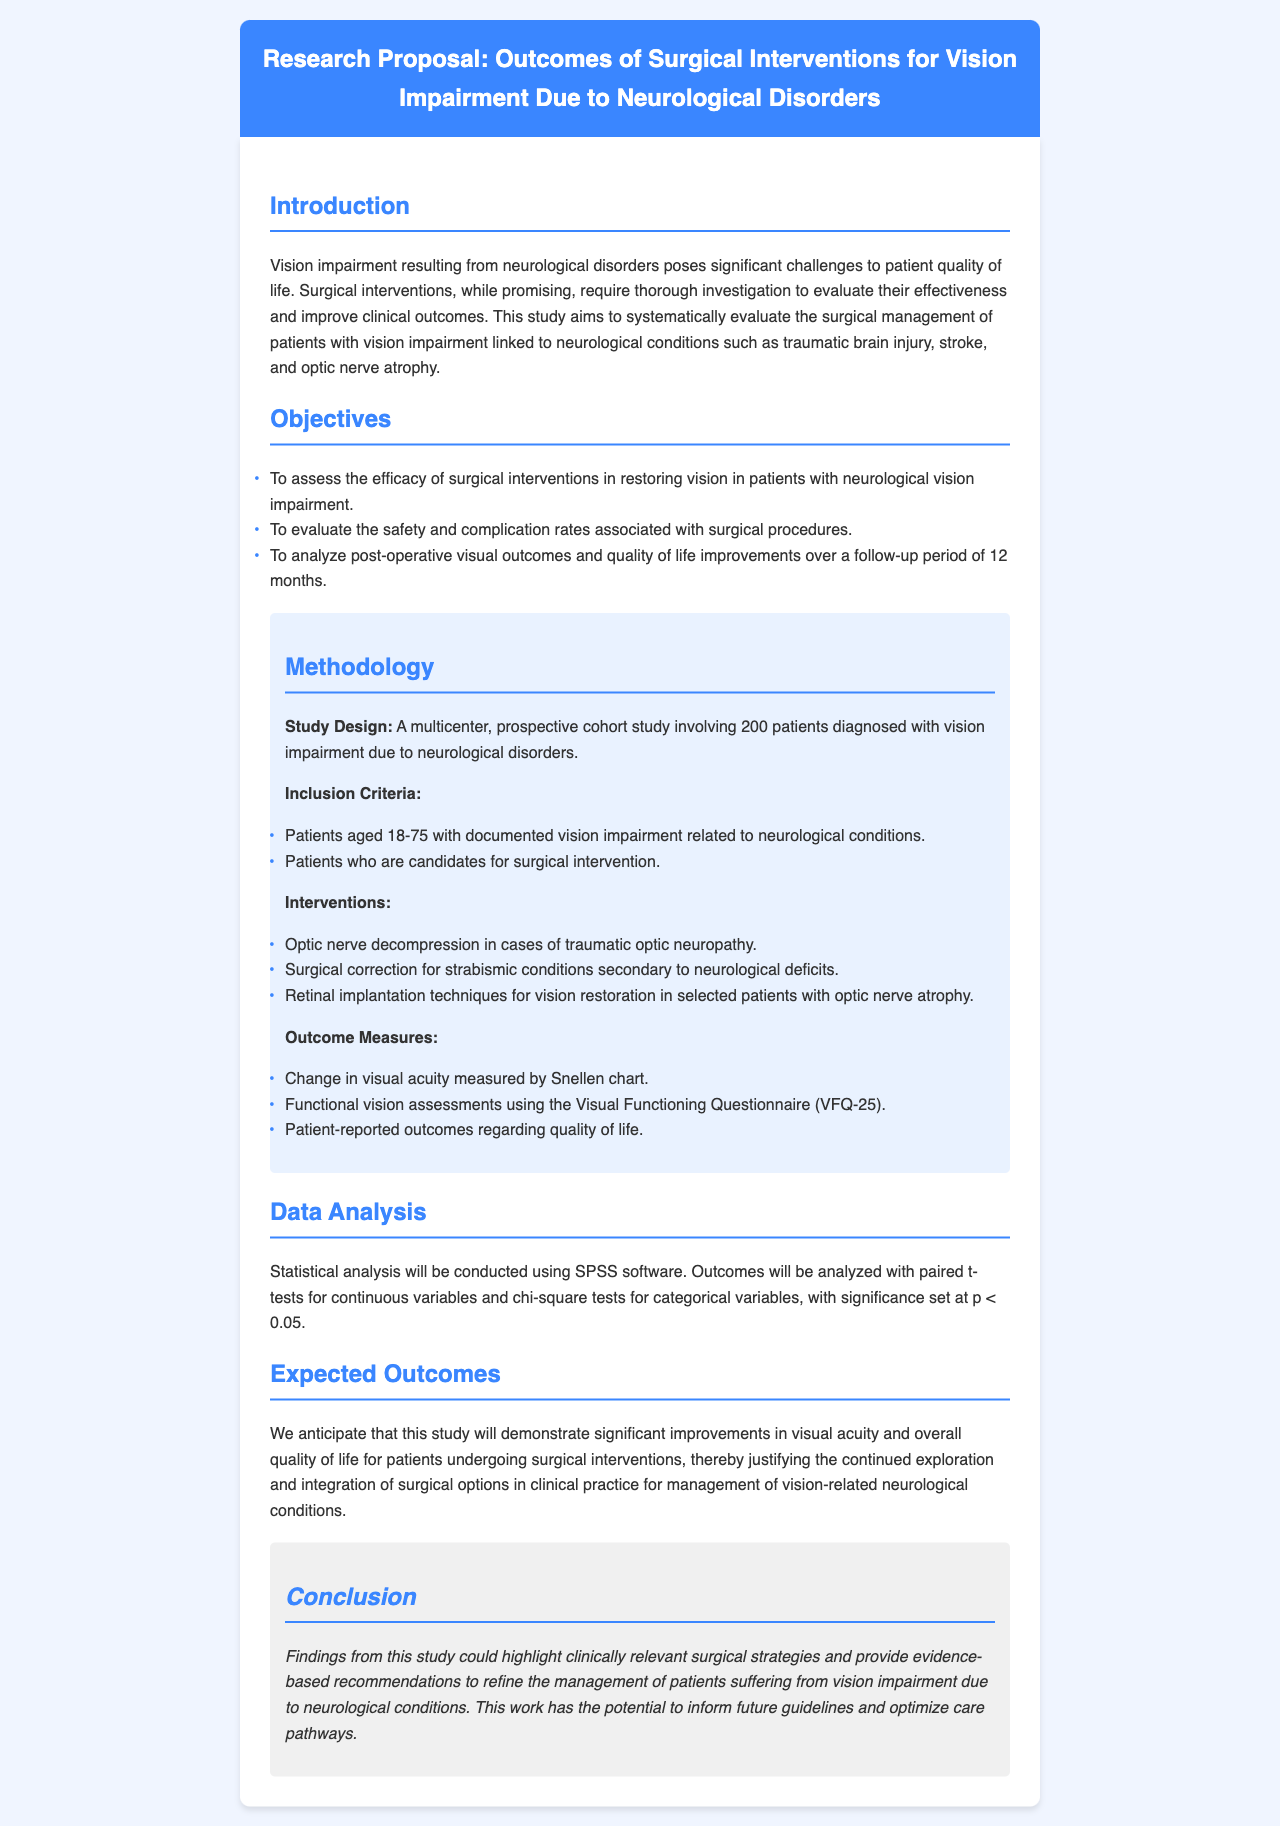What is the title of the research proposal? The title of the research proposal is found at the top of the document.
Answer: Outcomes of Surgical Interventions for Vision Impairment Due to Neurological Disorders How many patients will the study involve? The number of patients involved in the study is stated in the methodology section.
Answer: 200 What is a suggested intervention for traumatic optic neuropathy? This intervention is listed in the section discussing surgical options for various conditions.
Answer: Optic nerve decompression What is the age range of patients included in the study? The age range is mentioned in the inclusion criteria section.
Answer: 18-75 What statistical software will be used for analysis? The software used for data analysis is specified in the methodology part of the document.
Answer: SPSS What is the follow-up period for evaluating post-operative outcomes? The follow-up period is indicated in the objectives of the study.
Answer: 12 months What outcome measure involves a questionnaire? The specific outcome measure related to patient-reported outcomes is described in the outcome measures section.
Answer: Visual Functioning Questionnaire (VFQ-25) What are the anticipated outcomes of the study? The expected outcomes summarize the goals and anticipated results of the study.
Answer: Improvements in visual acuity and overall quality of life What type of study design is proposed? The study design is mentioned in the methodology section and describes the approach taken.
Answer: Multicenter, prospective cohort study 